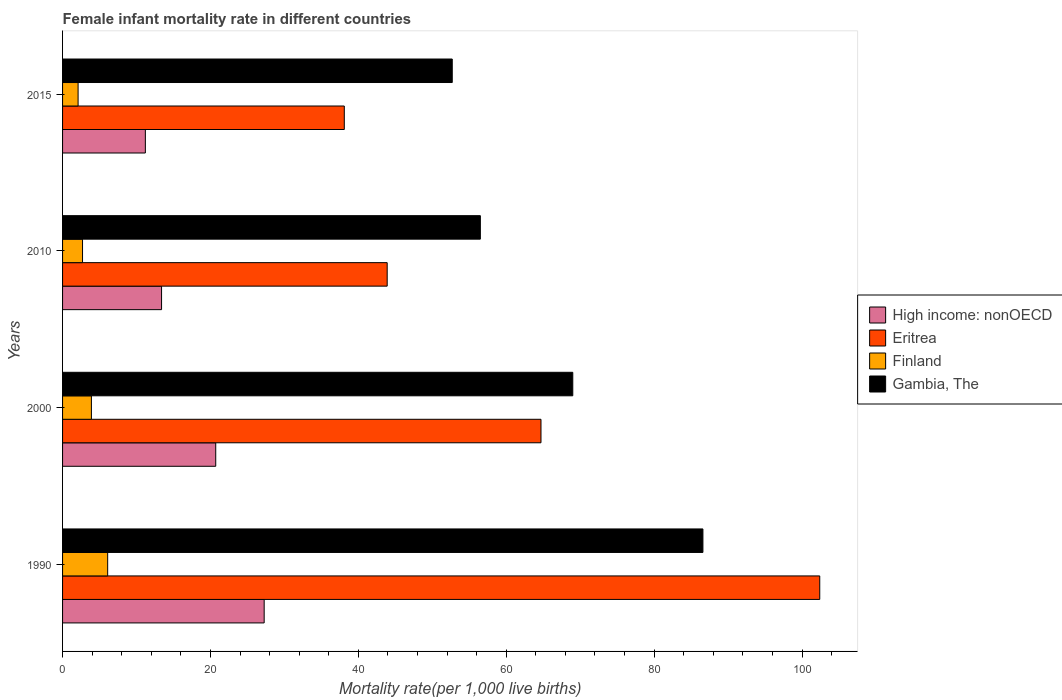How many groups of bars are there?
Provide a short and direct response. 4. Are the number of bars on each tick of the Y-axis equal?
Give a very brief answer. Yes. How many bars are there on the 1st tick from the top?
Provide a succinct answer. 4. What is the label of the 1st group of bars from the top?
Provide a short and direct response. 2015. In how many cases, is the number of bars for a given year not equal to the number of legend labels?
Provide a short and direct response. 0. What is the female infant mortality rate in Eritrea in 2010?
Your answer should be compact. 43.9. Across all years, what is the maximum female infant mortality rate in Eritrea?
Your answer should be very brief. 102.4. Across all years, what is the minimum female infant mortality rate in Finland?
Provide a short and direct response. 2.1. In which year was the female infant mortality rate in Gambia, The minimum?
Offer a terse response. 2015. What is the total female infant mortality rate in Eritrea in the graph?
Your answer should be compact. 249.1. What is the difference between the female infant mortality rate in High income: nonOECD in 2010 and the female infant mortality rate in Gambia, The in 2000?
Offer a terse response. -55.61. What is the average female infant mortality rate in Eritrea per year?
Ensure brevity in your answer.  62.28. In the year 2010, what is the difference between the female infant mortality rate in Gambia, The and female infant mortality rate in Eritrea?
Your answer should be compact. 12.6. What is the ratio of the female infant mortality rate in High income: nonOECD in 1990 to that in 2010?
Provide a succinct answer. 2.04. Is the female infant mortality rate in Gambia, The in 1990 less than that in 2010?
Provide a short and direct response. No. Is the difference between the female infant mortality rate in Gambia, The in 2000 and 2015 greater than the difference between the female infant mortality rate in Eritrea in 2000 and 2015?
Your answer should be compact. No. What is the difference between the highest and the second highest female infant mortality rate in Gambia, The?
Give a very brief answer. 17.6. What is the difference between the highest and the lowest female infant mortality rate in High income: nonOECD?
Provide a succinct answer. 16.07. In how many years, is the female infant mortality rate in High income: nonOECD greater than the average female infant mortality rate in High income: nonOECD taken over all years?
Provide a short and direct response. 2. What does the 4th bar from the bottom in 2000 represents?
Keep it short and to the point. Gambia, The. Is it the case that in every year, the sum of the female infant mortality rate in Gambia, The and female infant mortality rate in Finland is greater than the female infant mortality rate in High income: nonOECD?
Your answer should be very brief. Yes. How many years are there in the graph?
Give a very brief answer. 4. What is the difference between two consecutive major ticks on the X-axis?
Keep it short and to the point. 20. Does the graph contain any zero values?
Provide a succinct answer. No. How many legend labels are there?
Give a very brief answer. 4. What is the title of the graph?
Your answer should be very brief. Female infant mortality rate in different countries. Does "Germany" appear as one of the legend labels in the graph?
Make the answer very short. No. What is the label or title of the X-axis?
Give a very brief answer. Mortality rate(per 1,0 live births). What is the label or title of the Y-axis?
Offer a terse response. Years. What is the Mortality rate(per 1,000 live births) in High income: nonOECD in 1990?
Provide a succinct answer. 27.26. What is the Mortality rate(per 1,000 live births) in Eritrea in 1990?
Your answer should be compact. 102.4. What is the Mortality rate(per 1,000 live births) of Finland in 1990?
Make the answer very short. 6.1. What is the Mortality rate(per 1,000 live births) in Gambia, The in 1990?
Keep it short and to the point. 86.6. What is the Mortality rate(per 1,000 live births) in High income: nonOECD in 2000?
Ensure brevity in your answer.  20.71. What is the Mortality rate(per 1,000 live births) of Eritrea in 2000?
Make the answer very short. 64.7. What is the Mortality rate(per 1,000 live births) of Finland in 2000?
Keep it short and to the point. 3.9. What is the Mortality rate(per 1,000 live births) in Gambia, The in 2000?
Provide a short and direct response. 69. What is the Mortality rate(per 1,000 live births) of High income: nonOECD in 2010?
Ensure brevity in your answer.  13.39. What is the Mortality rate(per 1,000 live births) of Eritrea in 2010?
Make the answer very short. 43.9. What is the Mortality rate(per 1,000 live births) of Finland in 2010?
Your answer should be very brief. 2.7. What is the Mortality rate(per 1,000 live births) in Gambia, The in 2010?
Your response must be concise. 56.5. What is the Mortality rate(per 1,000 live births) of High income: nonOECD in 2015?
Provide a short and direct response. 11.2. What is the Mortality rate(per 1,000 live births) in Eritrea in 2015?
Keep it short and to the point. 38.1. What is the Mortality rate(per 1,000 live births) of Gambia, The in 2015?
Give a very brief answer. 52.7. Across all years, what is the maximum Mortality rate(per 1,000 live births) in High income: nonOECD?
Keep it short and to the point. 27.26. Across all years, what is the maximum Mortality rate(per 1,000 live births) in Eritrea?
Offer a very short reply. 102.4. Across all years, what is the maximum Mortality rate(per 1,000 live births) in Gambia, The?
Provide a short and direct response. 86.6. Across all years, what is the minimum Mortality rate(per 1,000 live births) of High income: nonOECD?
Offer a terse response. 11.2. Across all years, what is the minimum Mortality rate(per 1,000 live births) in Eritrea?
Provide a succinct answer. 38.1. Across all years, what is the minimum Mortality rate(per 1,000 live births) in Finland?
Your answer should be compact. 2.1. Across all years, what is the minimum Mortality rate(per 1,000 live births) in Gambia, The?
Your response must be concise. 52.7. What is the total Mortality rate(per 1,000 live births) in High income: nonOECD in the graph?
Give a very brief answer. 72.56. What is the total Mortality rate(per 1,000 live births) in Eritrea in the graph?
Provide a short and direct response. 249.1. What is the total Mortality rate(per 1,000 live births) in Finland in the graph?
Provide a short and direct response. 14.8. What is the total Mortality rate(per 1,000 live births) in Gambia, The in the graph?
Ensure brevity in your answer.  264.8. What is the difference between the Mortality rate(per 1,000 live births) in High income: nonOECD in 1990 and that in 2000?
Offer a very short reply. 6.55. What is the difference between the Mortality rate(per 1,000 live births) in Eritrea in 1990 and that in 2000?
Give a very brief answer. 37.7. What is the difference between the Mortality rate(per 1,000 live births) in High income: nonOECD in 1990 and that in 2010?
Your response must be concise. 13.88. What is the difference between the Mortality rate(per 1,000 live births) of Eritrea in 1990 and that in 2010?
Your response must be concise. 58.5. What is the difference between the Mortality rate(per 1,000 live births) of Finland in 1990 and that in 2010?
Your answer should be very brief. 3.4. What is the difference between the Mortality rate(per 1,000 live births) of Gambia, The in 1990 and that in 2010?
Your answer should be very brief. 30.1. What is the difference between the Mortality rate(per 1,000 live births) in High income: nonOECD in 1990 and that in 2015?
Your answer should be very brief. 16.07. What is the difference between the Mortality rate(per 1,000 live births) in Eritrea in 1990 and that in 2015?
Ensure brevity in your answer.  64.3. What is the difference between the Mortality rate(per 1,000 live births) of Finland in 1990 and that in 2015?
Give a very brief answer. 4. What is the difference between the Mortality rate(per 1,000 live births) of Gambia, The in 1990 and that in 2015?
Offer a very short reply. 33.9. What is the difference between the Mortality rate(per 1,000 live births) in High income: nonOECD in 2000 and that in 2010?
Your response must be concise. 7.33. What is the difference between the Mortality rate(per 1,000 live births) of Eritrea in 2000 and that in 2010?
Keep it short and to the point. 20.8. What is the difference between the Mortality rate(per 1,000 live births) in Finland in 2000 and that in 2010?
Your answer should be very brief. 1.2. What is the difference between the Mortality rate(per 1,000 live births) of High income: nonOECD in 2000 and that in 2015?
Keep it short and to the point. 9.52. What is the difference between the Mortality rate(per 1,000 live births) in Eritrea in 2000 and that in 2015?
Your answer should be very brief. 26.6. What is the difference between the Mortality rate(per 1,000 live births) of Finland in 2000 and that in 2015?
Keep it short and to the point. 1.8. What is the difference between the Mortality rate(per 1,000 live births) of Gambia, The in 2000 and that in 2015?
Offer a terse response. 16.3. What is the difference between the Mortality rate(per 1,000 live births) of High income: nonOECD in 2010 and that in 2015?
Your response must be concise. 2.19. What is the difference between the Mortality rate(per 1,000 live births) of High income: nonOECD in 1990 and the Mortality rate(per 1,000 live births) of Eritrea in 2000?
Offer a terse response. -37.44. What is the difference between the Mortality rate(per 1,000 live births) of High income: nonOECD in 1990 and the Mortality rate(per 1,000 live births) of Finland in 2000?
Provide a succinct answer. 23.36. What is the difference between the Mortality rate(per 1,000 live births) in High income: nonOECD in 1990 and the Mortality rate(per 1,000 live births) in Gambia, The in 2000?
Provide a short and direct response. -41.74. What is the difference between the Mortality rate(per 1,000 live births) of Eritrea in 1990 and the Mortality rate(per 1,000 live births) of Finland in 2000?
Ensure brevity in your answer.  98.5. What is the difference between the Mortality rate(per 1,000 live births) of Eritrea in 1990 and the Mortality rate(per 1,000 live births) of Gambia, The in 2000?
Keep it short and to the point. 33.4. What is the difference between the Mortality rate(per 1,000 live births) of Finland in 1990 and the Mortality rate(per 1,000 live births) of Gambia, The in 2000?
Ensure brevity in your answer.  -62.9. What is the difference between the Mortality rate(per 1,000 live births) of High income: nonOECD in 1990 and the Mortality rate(per 1,000 live births) of Eritrea in 2010?
Provide a short and direct response. -16.64. What is the difference between the Mortality rate(per 1,000 live births) in High income: nonOECD in 1990 and the Mortality rate(per 1,000 live births) in Finland in 2010?
Ensure brevity in your answer.  24.56. What is the difference between the Mortality rate(per 1,000 live births) of High income: nonOECD in 1990 and the Mortality rate(per 1,000 live births) of Gambia, The in 2010?
Give a very brief answer. -29.24. What is the difference between the Mortality rate(per 1,000 live births) in Eritrea in 1990 and the Mortality rate(per 1,000 live births) in Finland in 2010?
Give a very brief answer. 99.7. What is the difference between the Mortality rate(per 1,000 live births) of Eritrea in 1990 and the Mortality rate(per 1,000 live births) of Gambia, The in 2010?
Offer a very short reply. 45.9. What is the difference between the Mortality rate(per 1,000 live births) of Finland in 1990 and the Mortality rate(per 1,000 live births) of Gambia, The in 2010?
Ensure brevity in your answer.  -50.4. What is the difference between the Mortality rate(per 1,000 live births) of High income: nonOECD in 1990 and the Mortality rate(per 1,000 live births) of Eritrea in 2015?
Give a very brief answer. -10.84. What is the difference between the Mortality rate(per 1,000 live births) of High income: nonOECD in 1990 and the Mortality rate(per 1,000 live births) of Finland in 2015?
Provide a succinct answer. 25.16. What is the difference between the Mortality rate(per 1,000 live births) of High income: nonOECD in 1990 and the Mortality rate(per 1,000 live births) of Gambia, The in 2015?
Your response must be concise. -25.44. What is the difference between the Mortality rate(per 1,000 live births) in Eritrea in 1990 and the Mortality rate(per 1,000 live births) in Finland in 2015?
Your answer should be compact. 100.3. What is the difference between the Mortality rate(per 1,000 live births) of Eritrea in 1990 and the Mortality rate(per 1,000 live births) of Gambia, The in 2015?
Your response must be concise. 49.7. What is the difference between the Mortality rate(per 1,000 live births) of Finland in 1990 and the Mortality rate(per 1,000 live births) of Gambia, The in 2015?
Ensure brevity in your answer.  -46.6. What is the difference between the Mortality rate(per 1,000 live births) in High income: nonOECD in 2000 and the Mortality rate(per 1,000 live births) in Eritrea in 2010?
Provide a succinct answer. -23.19. What is the difference between the Mortality rate(per 1,000 live births) of High income: nonOECD in 2000 and the Mortality rate(per 1,000 live births) of Finland in 2010?
Give a very brief answer. 18.01. What is the difference between the Mortality rate(per 1,000 live births) of High income: nonOECD in 2000 and the Mortality rate(per 1,000 live births) of Gambia, The in 2010?
Make the answer very short. -35.79. What is the difference between the Mortality rate(per 1,000 live births) of Eritrea in 2000 and the Mortality rate(per 1,000 live births) of Finland in 2010?
Ensure brevity in your answer.  62. What is the difference between the Mortality rate(per 1,000 live births) of Finland in 2000 and the Mortality rate(per 1,000 live births) of Gambia, The in 2010?
Give a very brief answer. -52.6. What is the difference between the Mortality rate(per 1,000 live births) in High income: nonOECD in 2000 and the Mortality rate(per 1,000 live births) in Eritrea in 2015?
Your answer should be very brief. -17.39. What is the difference between the Mortality rate(per 1,000 live births) in High income: nonOECD in 2000 and the Mortality rate(per 1,000 live births) in Finland in 2015?
Give a very brief answer. 18.61. What is the difference between the Mortality rate(per 1,000 live births) of High income: nonOECD in 2000 and the Mortality rate(per 1,000 live births) of Gambia, The in 2015?
Offer a very short reply. -31.99. What is the difference between the Mortality rate(per 1,000 live births) in Eritrea in 2000 and the Mortality rate(per 1,000 live births) in Finland in 2015?
Provide a short and direct response. 62.6. What is the difference between the Mortality rate(per 1,000 live births) in Eritrea in 2000 and the Mortality rate(per 1,000 live births) in Gambia, The in 2015?
Offer a terse response. 12. What is the difference between the Mortality rate(per 1,000 live births) of Finland in 2000 and the Mortality rate(per 1,000 live births) of Gambia, The in 2015?
Keep it short and to the point. -48.8. What is the difference between the Mortality rate(per 1,000 live births) of High income: nonOECD in 2010 and the Mortality rate(per 1,000 live births) of Eritrea in 2015?
Ensure brevity in your answer.  -24.71. What is the difference between the Mortality rate(per 1,000 live births) in High income: nonOECD in 2010 and the Mortality rate(per 1,000 live births) in Finland in 2015?
Make the answer very short. 11.29. What is the difference between the Mortality rate(per 1,000 live births) of High income: nonOECD in 2010 and the Mortality rate(per 1,000 live births) of Gambia, The in 2015?
Offer a very short reply. -39.31. What is the difference between the Mortality rate(per 1,000 live births) in Eritrea in 2010 and the Mortality rate(per 1,000 live births) in Finland in 2015?
Provide a succinct answer. 41.8. What is the difference between the Mortality rate(per 1,000 live births) in Eritrea in 2010 and the Mortality rate(per 1,000 live births) in Gambia, The in 2015?
Offer a very short reply. -8.8. What is the average Mortality rate(per 1,000 live births) of High income: nonOECD per year?
Ensure brevity in your answer.  18.14. What is the average Mortality rate(per 1,000 live births) of Eritrea per year?
Provide a short and direct response. 62.27. What is the average Mortality rate(per 1,000 live births) in Finland per year?
Your answer should be compact. 3.7. What is the average Mortality rate(per 1,000 live births) of Gambia, The per year?
Offer a very short reply. 66.2. In the year 1990, what is the difference between the Mortality rate(per 1,000 live births) in High income: nonOECD and Mortality rate(per 1,000 live births) in Eritrea?
Ensure brevity in your answer.  -75.14. In the year 1990, what is the difference between the Mortality rate(per 1,000 live births) in High income: nonOECD and Mortality rate(per 1,000 live births) in Finland?
Make the answer very short. 21.16. In the year 1990, what is the difference between the Mortality rate(per 1,000 live births) in High income: nonOECD and Mortality rate(per 1,000 live births) in Gambia, The?
Ensure brevity in your answer.  -59.34. In the year 1990, what is the difference between the Mortality rate(per 1,000 live births) of Eritrea and Mortality rate(per 1,000 live births) of Finland?
Your answer should be compact. 96.3. In the year 1990, what is the difference between the Mortality rate(per 1,000 live births) in Eritrea and Mortality rate(per 1,000 live births) in Gambia, The?
Give a very brief answer. 15.8. In the year 1990, what is the difference between the Mortality rate(per 1,000 live births) of Finland and Mortality rate(per 1,000 live births) of Gambia, The?
Your answer should be compact. -80.5. In the year 2000, what is the difference between the Mortality rate(per 1,000 live births) of High income: nonOECD and Mortality rate(per 1,000 live births) of Eritrea?
Your answer should be compact. -43.99. In the year 2000, what is the difference between the Mortality rate(per 1,000 live births) of High income: nonOECD and Mortality rate(per 1,000 live births) of Finland?
Your answer should be compact. 16.81. In the year 2000, what is the difference between the Mortality rate(per 1,000 live births) of High income: nonOECD and Mortality rate(per 1,000 live births) of Gambia, The?
Offer a very short reply. -48.29. In the year 2000, what is the difference between the Mortality rate(per 1,000 live births) in Eritrea and Mortality rate(per 1,000 live births) in Finland?
Provide a short and direct response. 60.8. In the year 2000, what is the difference between the Mortality rate(per 1,000 live births) of Finland and Mortality rate(per 1,000 live births) of Gambia, The?
Ensure brevity in your answer.  -65.1. In the year 2010, what is the difference between the Mortality rate(per 1,000 live births) in High income: nonOECD and Mortality rate(per 1,000 live births) in Eritrea?
Provide a succinct answer. -30.51. In the year 2010, what is the difference between the Mortality rate(per 1,000 live births) in High income: nonOECD and Mortality rate(per 1,000 live births) in Finland?
Ensure brevity in your answer.  10.69. In the year 2010, what is the difference between the Mortality rate(per 1,000 live births) in High income: nonOECD and Mortality rate(per 1,000 live births) in Gambia, The?
Keep it short and to the point. -43.11. In the year 2010, what is the difference between the Mortality rate(per 1,000 live births) in Eritrea and Mortality rate(per 1,000 live births) in Finland?
Offer a terse response. 41.2. In the year 2010, what is the difference between the Mortality rate(per 1,000 live births) of Finland and Mortality rate(per 1,000 live births) of Gambia, The?
Offer a terse response. -53.8. In the year 2015, what is the difference between the Mortality rate(per 1,000 live births) of High income: nonOECD and Mortality rate(per 1,000 live births) of Eritrea?
Give a very brief answer. -26.9. In the year 2015, what is the difference between the Mortality rate(per 1,000 live births) in High income: nonOECD and Mortality rate(per 1,000 live births) in Finland?
Provide a short and direct response. 9.1. In the year 2015, what is the difference between the Mortality rate(per 1,000 live births) in High income: nonOECD and Mortality rate(per 1,000 live births) in Gambia, The?
Give a very brief answer. -41.5. In the year 2015, what is the difference between the Mortality rate(per 1,000 live births) in Eritrea and Mortality rate(per 1,000 live births) in Finland?
Provide a succinct answer. 36. In the year 2015, what is the difference between the Mortality rate(per 1,000 live births) in Eritrea and Mortality rate(per 1,000 live births) in Gambia, The?
Keep it short and to the point. -14.6. In the year 2015, what is the difference between the Mortality rate(per 1,000 live births) in Finland and Mortality rate(per 1,000 live births) in Gambia, The?
Provide a succinct answer. -50.6. What is the ratio of the Mortality rate(per 1,000 live births) of High income: nonOECD in 1990 to that in 2000?
Your answer should be compact. 1.32. What is the ratio of the Mortality rate(per 1,000 live births) in Eritrea in 1990 to that in 2000?
Your answer should be compact. 1.58. What is the ratio of the Mortality rate(per 1,000 live births) in Finland in 1990 to that in 2000?
Ensure brevity in your answer.  1.56. What is the ratio of the Mortality rate(per 1,000 live births) in Gambia, The in 1990 to that in 2000?
Provide a succinct answer. 1.26. What is the ratio of the Mortality rate(per 1,000 live births) of High income: nonOECD in 1990 to that in 2010?
Your answer should be very brief. 2.04. What is the ratio of the Mortality rate(per 1,000 live births) in Eritrea in 1990 to that in 2010?
Make the answer very short. 2.33. What is the ratio of the Mortality rate(per 1,000 live births) in Finland in 1990 to that in 2010?
Ensure brevity in your answer.  2.26. What is the ratio of the Mortality rate(per 1,000 live births) in Gambia, The in 1990 to that in 2010?
Your response must be concise. 1.53. What is the ratio of the Mortality rate(per 1,000 live births) in High income: nonOECD in 1990 to that in 2015?
Your answer should be compact. 2.44. What is the ratio of the Mortality rate(per 1,000 live births) in Eritrea in 1990 to that in 2015?
Make the answer very short. 2.69. What is the ratio of the Mortality rate(per 1,000 live births) of Finland in 1990 to that in 2015?
Offer a terse response. 2.9. What is the ratio of the Mortality rate(per 1,000 live births) of Gambia, The in 1990 to that in 2015?
Offer a terse response. 1.64. What is the ratio of the Mortality rate(per 1,000 live births) in High income: nonOECD in 2000 to that in 2010?
Provide a short and direct response. 1.55. What is the ratio of the Mortality rate(per 1,000 live births) in Eritrea in 2000 to that in 2010?
Offer a terse response. 1.47. What is the ratio of the Mortality rate(per 1,000 live births) in Finland in 2000 to that in 2010?
Ensure brevity in your answer.  1.44. What is the ratio of the Mortality rate(per 1,000 live births) of Gambia, The in 2000 to that in 2010?
Keep it short and to the point. 1.22. What is the ratio of the Mortality rate(per 1,000 live births) in High income: nonOECD in 2000 to that in 2015?
Your response must be concise. 1.85. What is the ratio of the Mortality rate(per 1,000 live births) in Eritrea in 2000 to that in 2015?
Your response must be concise. 1.7. What is the ratio of the Mortality rate(per 1,000 live births) in Finland in 2000 to that in 2015?
Your answer should be very brief. 1.86. What is the ratio of the Mortality rate(per 1,000 live births) in Gambia, The in 2000 to that in 2015?
Provide a short and direct response. 1.31. What is the ratio of the Mortality rate(per 1,000 live births) in High income: nonOECD in 2010 to that in 2015?
Keep it short and to the point. 1.2. What is the ratio of the Mortality rate(per 1,000 live births) of Eritrea in 2010 to that in 2015?
Your answer should be compact. 1.15. What is the ratio of the Mortality rate(per 1,000 live births) of Gambia, The in 2010 to that in 2015?
Provide a short and direct response. 1.07. What is the difference between the highest and the second highest Mortality rate(per 1,000 live births) in High income: nonOECD?
Your answer should be compact. 6.55. What is the difference between the highest and the second highest Mortality rate(per 1,000 live births) of Eritrea?
Ensure brevity in your answer.  37.7. What is the difference between the highest and the second highest Mortality rate(per 1,000 live births) in Finland?
Your response must be concise. 2.2. What is the difference between the highest and the second highest Mortality rate(per 1,000 live births) in Gambia, The?
Your answer should be compact. 17.6. What is the difference between the highest and the lowest Mortality rate(per 1,000 live births) of High income: nonOECD?
Make the answer very short. 16.07. What is the difference between the highest and the lowest Mortality rate(per 1,000 live births) in Eritrea?
Provide a succinct answer. 64.3. What is the difference between the highest and the lowest Mortality rate(per 1,000 live births) of Finland?
Give a very brief answer. 4. What is the difference between the highest and the lowest Mortality rate(per 1,000 live births) of Gambia, The?
Make the answer very short. 33.9. 